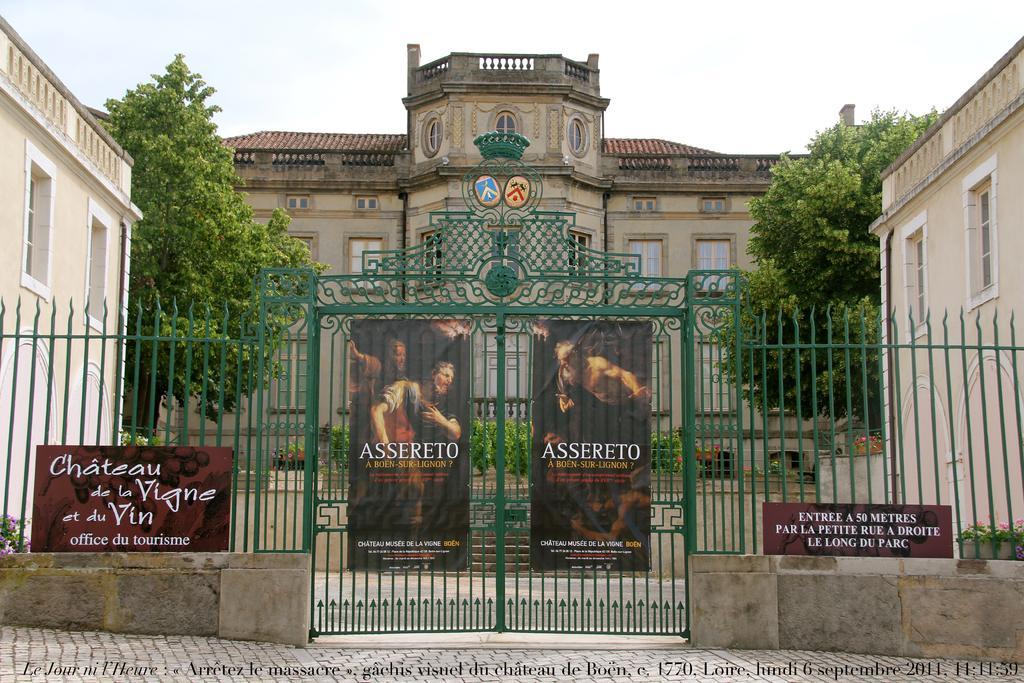Please provide a concise description of this image. In the picture we can see a building with windows and glasses to it and near to it we can see some plants and besides the building we can see trees and buildings and in front of it we can see a railing and gate to it which is green in color and two posters on it with a name ASSERETO. 